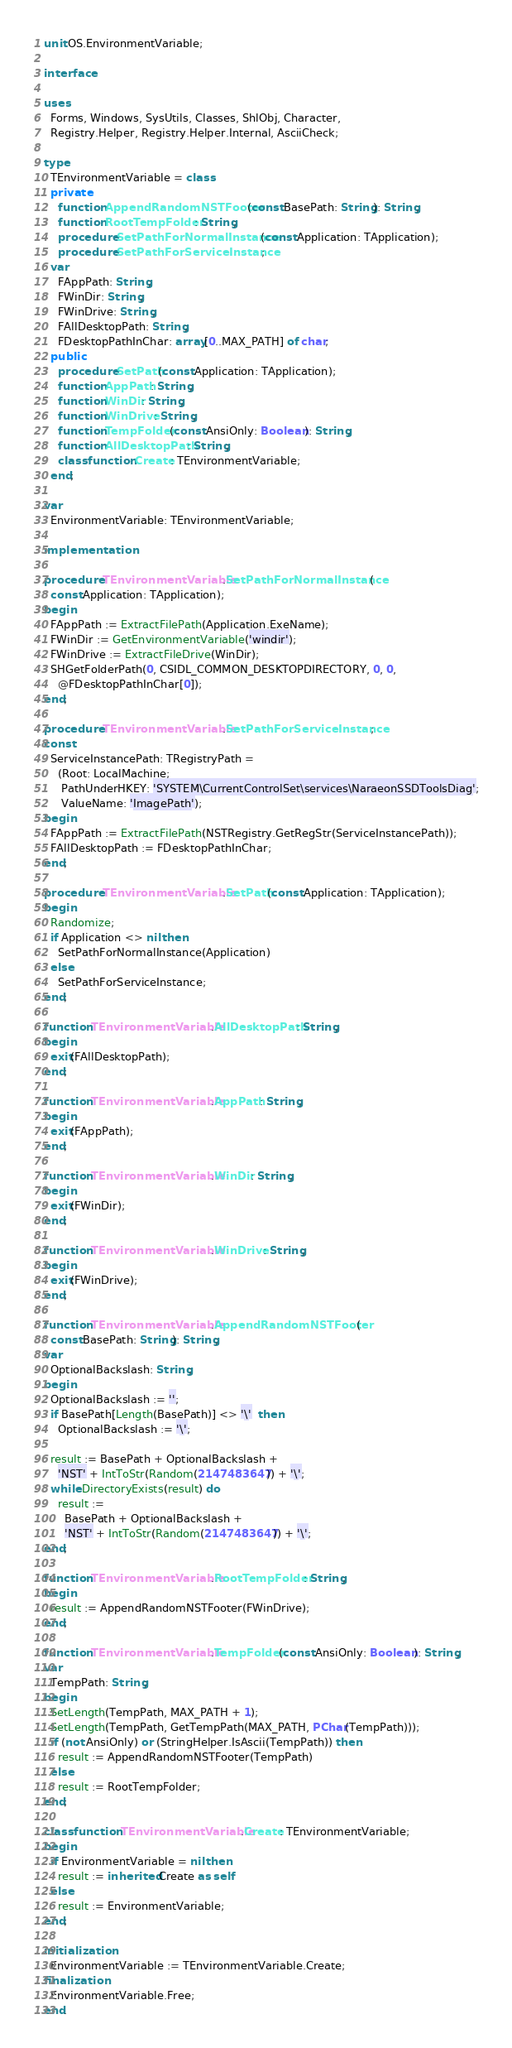Convert code to text. <code><loc_0><loc_0><loc_500><loc_500><_Pascal_>unit OS.EnvironmentVariable;

interface

uses
  Forms, Windows, SysUtils, Classes, ShlObj, Character,
  Registry.Helper, Registry.Helper.Internal, AsciiCheck;

type
  TEnvironmentVariable = class
  private
    function AppendRandomNSTFooter(const BasePath: String): String;
    function RootTempFolder: String;
    procedure SetPathForNormalInstance(const Application: TApplication);
    procedure SetPathForServiceInstance;
  var
    FAppPath: String;
    FWinDir: String;
    FWinDrive: String;
    FAllDesktopPath: String;
    FDesktopPathInChar: array[0..MAX_PATH] of char;
  public
    procedure SetPath(const Application: TApplication);
    function AppPath: String;
    function WinDir: String;
    function WinDrive: String;
    function TempFolder(const AnsiOnly: Boolean): String;
    function AllDesktopPath: String;
    class function Create: TEnvironmentVariable;
  end;

var
  EnvironmentVariable: TEnvironmentVariable;

implementation

procedure TEnvironmentVariable.SetPathForNormalInstance(
  const Application: TApplication);
begin
  FAppPath := ExtractFilePath(Application.ExeName);
  FWinDir := GetEnvironmentVariable('windir');
  FWinDrive := ExtractFileDrive(WinDir);
  SHGetFolderPath(0, CSIDL_COMMON_DESKTOPDIRECTORY, 0, 0,
    @FDesktopPathInChar[0]);
end;

procedure TEnvironmentVariable.SetPathForServiceInstance;
const
  ServiceInstancePath: TRegistryPath =
    (Root: LocalMachine;
     PathUnderHKEY: 'SYSTEM\CurrentControlSet\services\NaraeonSSDToolsDiag';
     ValueName: 'ImagePath');
begin
  FAppPath := ExtractFilePath(NSTRegistry.GetRegStr(ServiceInstancePath));
  FAllDesktopPath := FDesktopPathInChar;
end;

procedure TEnvironmentVariable.SetPath(const Application: TApplication);
begin
  Randomize;
  if Application <> nil then
    SetPathForNormalInstance(Application)
  else
    SetPathForServiceInstance;
end;

function TEnvironmentVariable.AllDesktopPath: String;
begin
  exit(FAllDesktopPath);
end;

function TEnvironmentVariable.AppPath: String;
begin
  exit(FAppPath);
end;

function TEnvironmentVariable.WinDir: String;
begin
  exit(FWinDir);
end;

function TEnvironmentVariable.WinDrive: String;
begin
  exit(FWinDrive);
end;

function TEnvironmentVariable.AppendRandomNSTFooter(
  const BasePath: String): String;
var
  OptionalBackslash: String;
begin
  OptionalBackslash := '';
  if BasePath[Length(BasePath)] <> '\'  then
    OptionalBackslash := '\';

  result := BasePath + OptionalBackslash +
    'NST' + IntToStr(Random(2147483647)) + '\';
  while DirectoryExists(result) do
    result :=
      BasePath + OptionalBackslash +
      'NST' + IntToStr(Random(2147483647)) + '\';
end;

function TEnvironmentVariable.RootTempFolder: String;
begin
  result := AppendRandomNSTFooter(FWinDrive);
end;

function TEnvironmentVariable.TempFolder(const AnsiOnly: Boolean): String;
var
  TempPath: String;
begin
  SetLength(TempPath, MAX_PATH + 1);
  SetLength(TempPath, GetTempPath(MAX_PATH, PChar(TempPath)));
  if (not AnsiOnly) or (StringHelper.IsAscii(TempPath)) then
    result := AppendRandomNSTFooter(TempPath)
  else
    result := RootTempFolder;
end;

class function TEnvironmentVariable.Create: TEnvironmentVariable;
begin
  if EnvironmentVariable = nil then
    result := inherited Create as self
  else
    result := EnvironmentVariable;
end;

initialization
  EnvironmentVariable := TEnvironmentVariable.Create;
finalization
  EnvironmentVariable.Free;
end.
</code> 